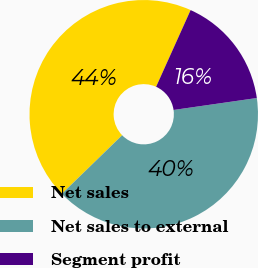Convert chart to OTSL. <chart><loc_0><loc_0><loc_500><loc_500><pie_chart><fcel>Net sales<fcel>Net sales to external<fcel>Segment profit<nl><fcel>44.0%<fcel>40.0%<fcel>16.0%<nl></chart> 